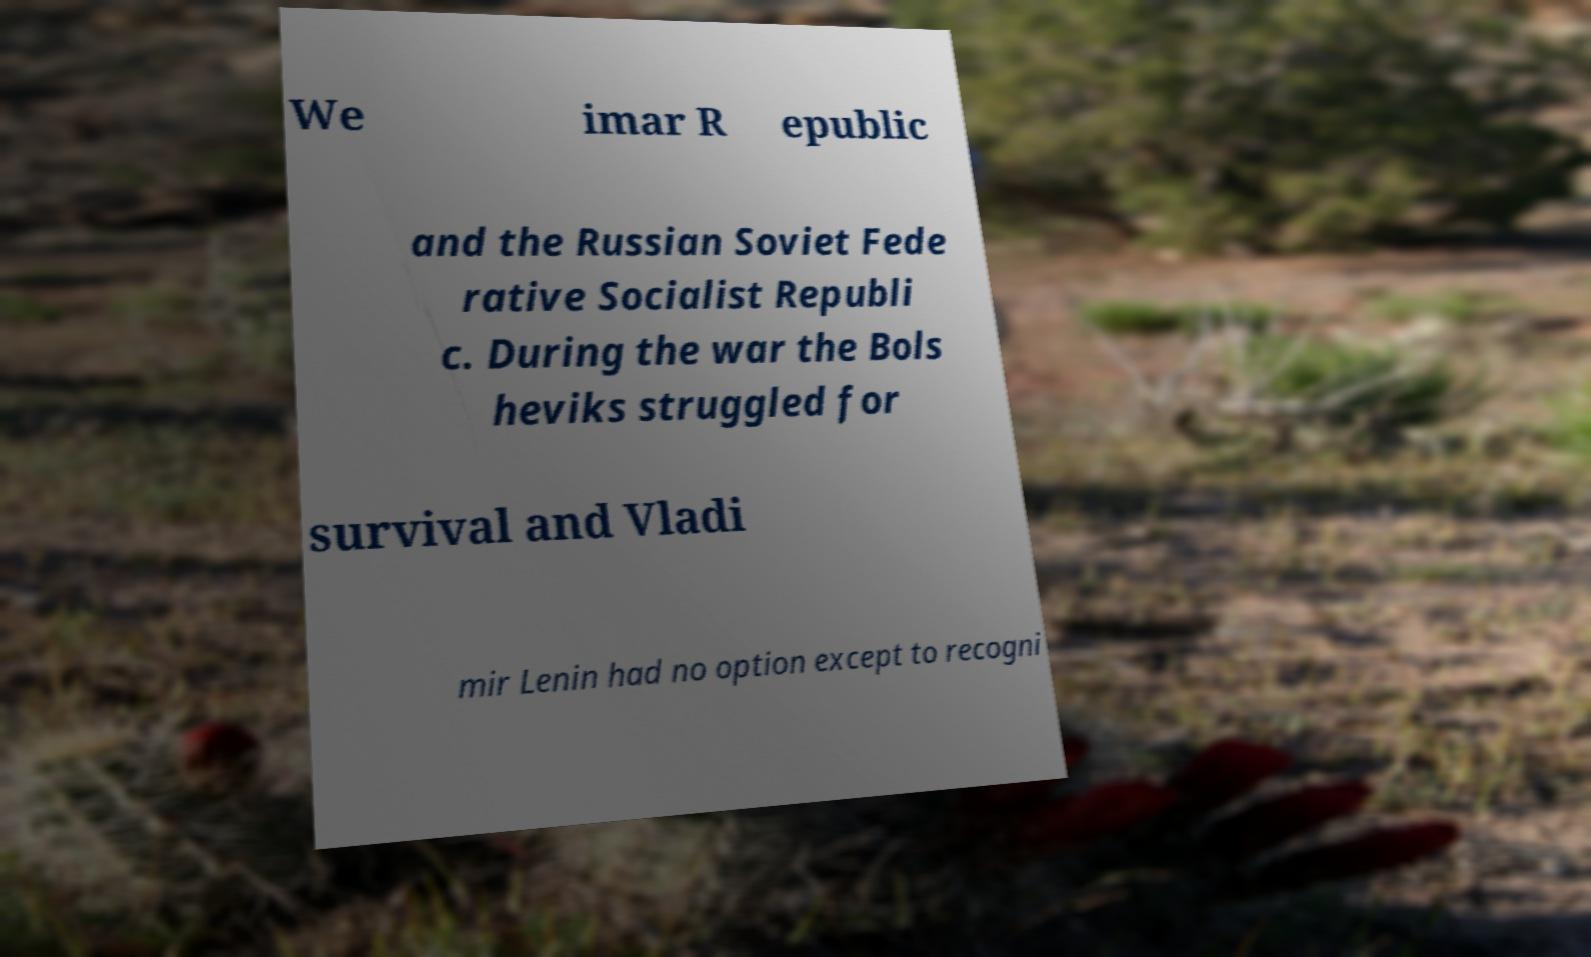There's text embedded in this image that I need extracted. Can you transcribe it verbatim? We imar R epublic and the Russian Soviet Fede rative Socialist Republi c. During the war the Bols heviks struggled for survival and Vladi mir Lenin had no option except to recogni 